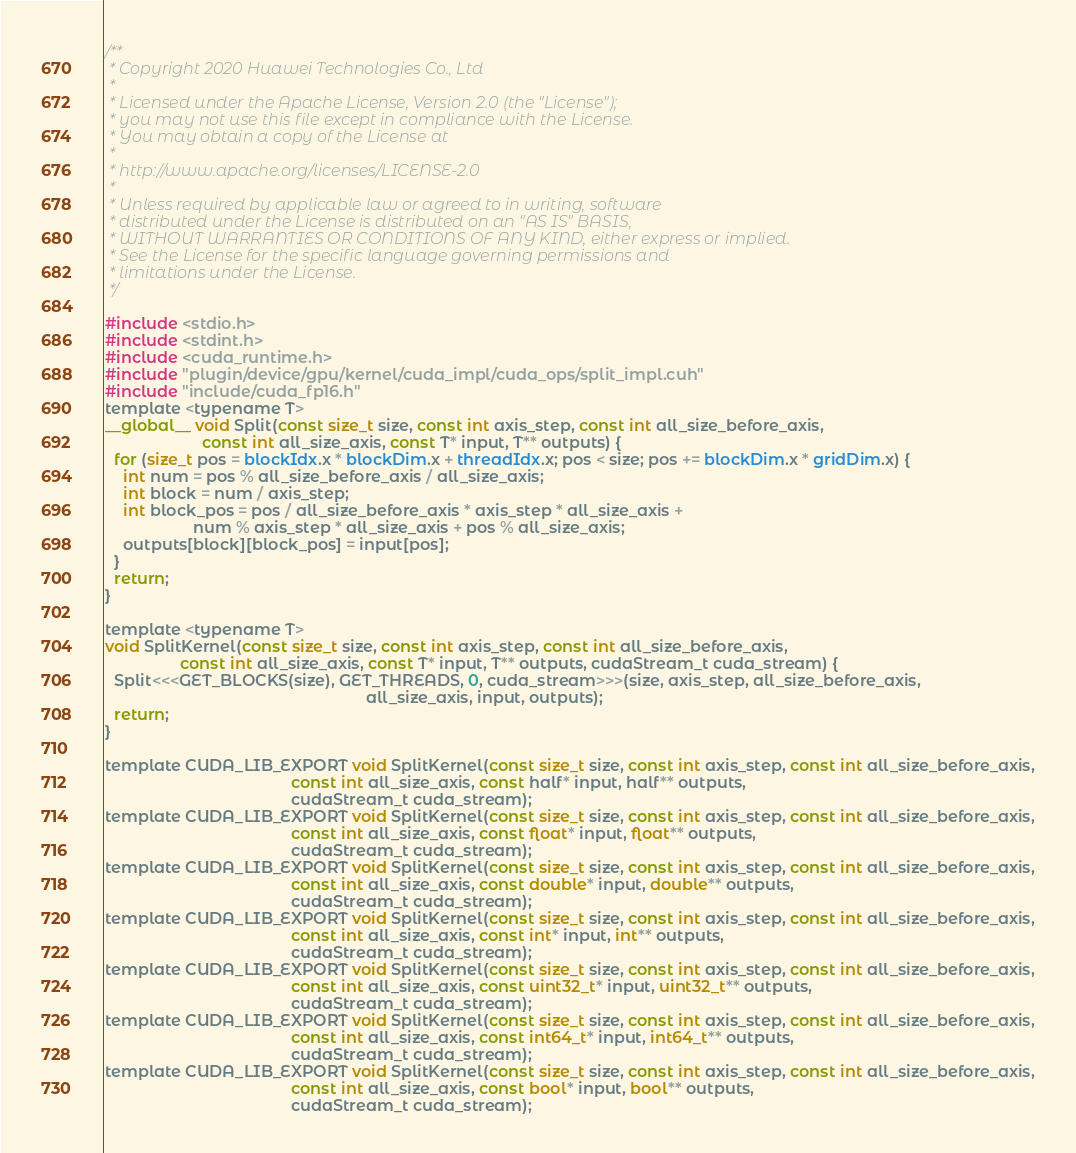Convert code to text. <code><loc_0><loc_0><loc_500><loc_500><_Cuda_>/**
 * Copyright 2020 Huawei Technologies Co., Ltd
 *
 * Licensed under the Apache License, Version 2.0 (the "License");
 * you may not use this file except in compliance with the License.
 * You may obtain a copy of the License at
 *
 * http://www.apache.org/licenses/LICENSE-2.0
 *
 * Unless required by applicable law or agreed to in writing, software
 * distributed under the License is distributed on an "AS IS" BASIS,
 * WITHOUT WARRANTIES OR CONDITIONS OF ANY KIND, either express or implied.
 * See the License for the specific language governing permissions and
 * limitations under the License.
 */

#include <stdio.h>
#include <stdint.h>
#include <cuda_runtime.h>
#include "plugin/device/gpu/kernel/cuda_impl/cuda_ops/split_impl.cuh"
#include "include/cuda_fp16.h"
template <typename T>
__global__ void Split(const size_t size, const int axis_step, const int all_size_before_axis,
                      const int all_size_axis, const T* input, T** outputs) {
  for (size_t pos = blockIdx.x * blockDim.x + threadIdx.x; pos < size; pos += blockDim.x * gridDim.x) {
    int num = pos % all_size_before_axis / all_size_axis;
    int block = num / axis_step;
    int block_pos = pos / all_size_before_axis * axis_step * all_size_axis +
                    num % axis_step * all_size_axis + pos % all_size_axis;
    outputs[block][block_pos] = input[pos];
  }
  return;
}

template <typename T>
void SplitKernel(const size_t size, const int axis_step, const int all_size_before_axis,
                 const int all_size_axis, const T* input, T** outputs, cudaStream_t cuda_stream) {
  Split<<<GET_BLOCKS(size), GET_THREADS, 0, cuda_stream>>>(size, axis_step, all_size_before_axis,
                                                           all_size_axis, input, outputs);
  return;
}

template CUDA_LIB_EXPORT void SplitKernel(const size_t size, const int axis_step, const int all_size_before_axis,
                                          const int all_size_axis, const half* input, half** outputs,
                                          cudaStream_t cuda_stream);
template CUDA_LIB_EXPORT void SplitKernel(const size_t size, const int axis_step, const int all_size_before_axis,
                                          const int all_size_axis, const float* input, float** outputs,
                                          cudaStream_t cuda_stream);
template CUDA_LIB_EXPORT void SplitKernel(const size_t size, const int axis_step, const int all_size_before_axis,
                                          const int all_size_axis, const double* input, double** outputs,
                                          cudaStream_t cuda_stream);
template CUDA_LIB_EXPORT void SplitKernel(const size_t size, const int axis_step, const int all_size_before_axis,
                                          const int all_size_axis, const int* input, int** outputs,
                                          cudaStream_t cuda_stream);
template CUDA_LIB_EXPORT void SplitKernel(const size_t size, const int axis_step, const int all_size_before_axis,
                                          const int all_size_axis, const uint32_t* input, uint32_t** outputs,
                                          cudaStream_t cuda_stream);
template CUDA_LIB_EXPORT void SplitKernel(const size_t size, const int axis_step, const int all_size_before_axis,
                                          const int all_size_axis, const int64_t* input, int64_t** outputs,
                                          cudaStream_t cuda_stream);
template CUDA_LIB_EXPORT void SplitKernel(const size_t size, const int axis_step, const int all_size_before_axis,
                                          const int all_size_axis, const bool* input, bool** outputs,
                                          cudaStream_t cuda_stream);
</code> 